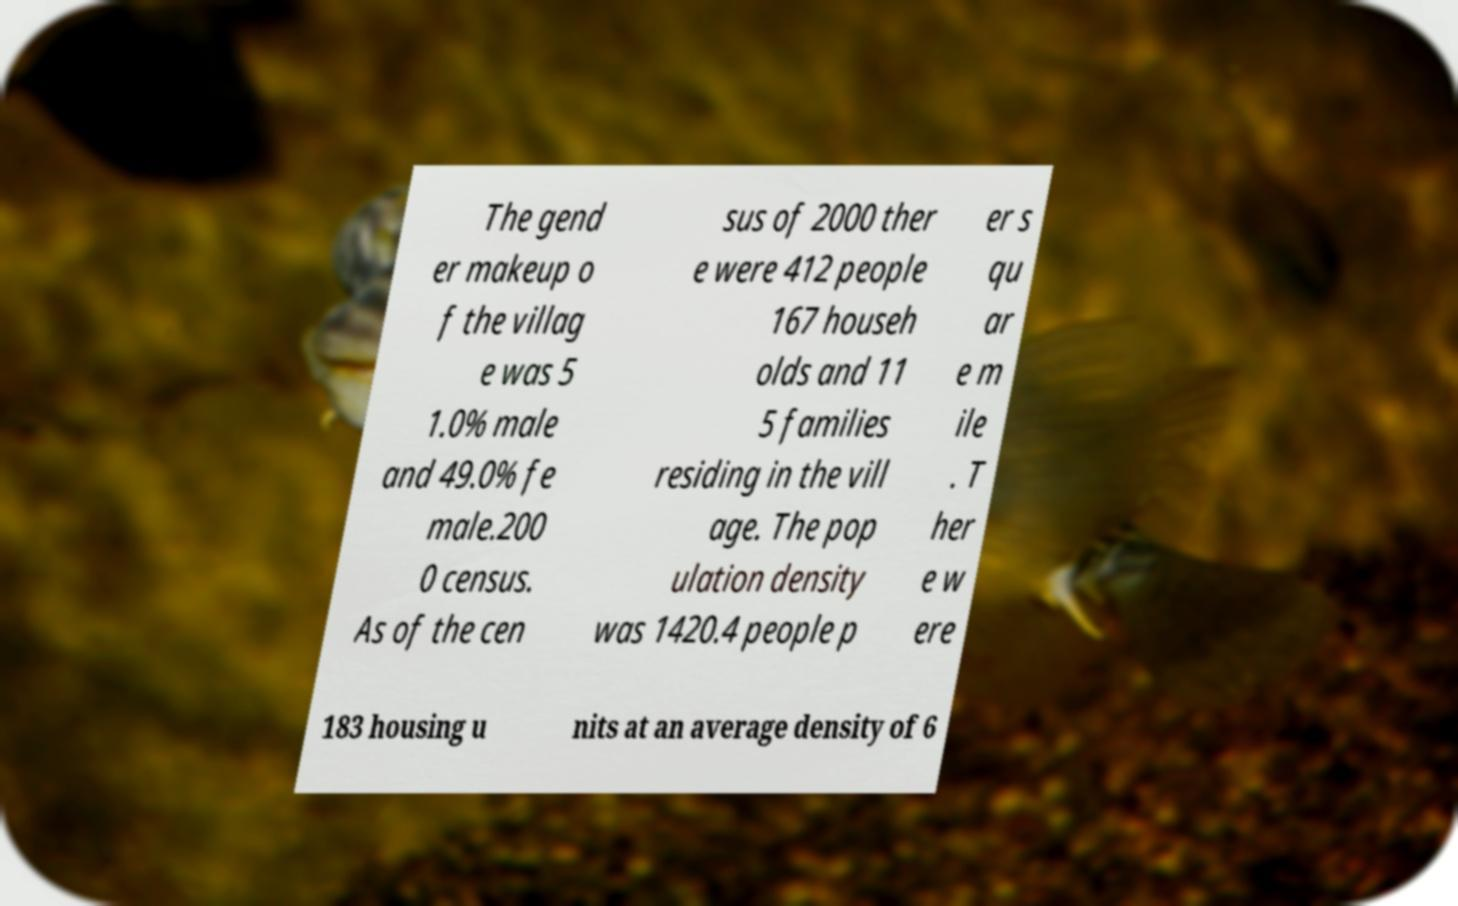What messages or text are displayed in this image? I need them in a readable, typed format. The gend er makeup o f the villag e was 5 1.0% male and 49.0% fe male.200 0 census. As of the cen sus of 2000 ther e were 412 people 167 househ olds and 11 5 families residing in the vill age. The pop ulation density was 1420.4 people p er s qu ar e m ile . T her e w ere 183 housing u nits at an average density of 6 